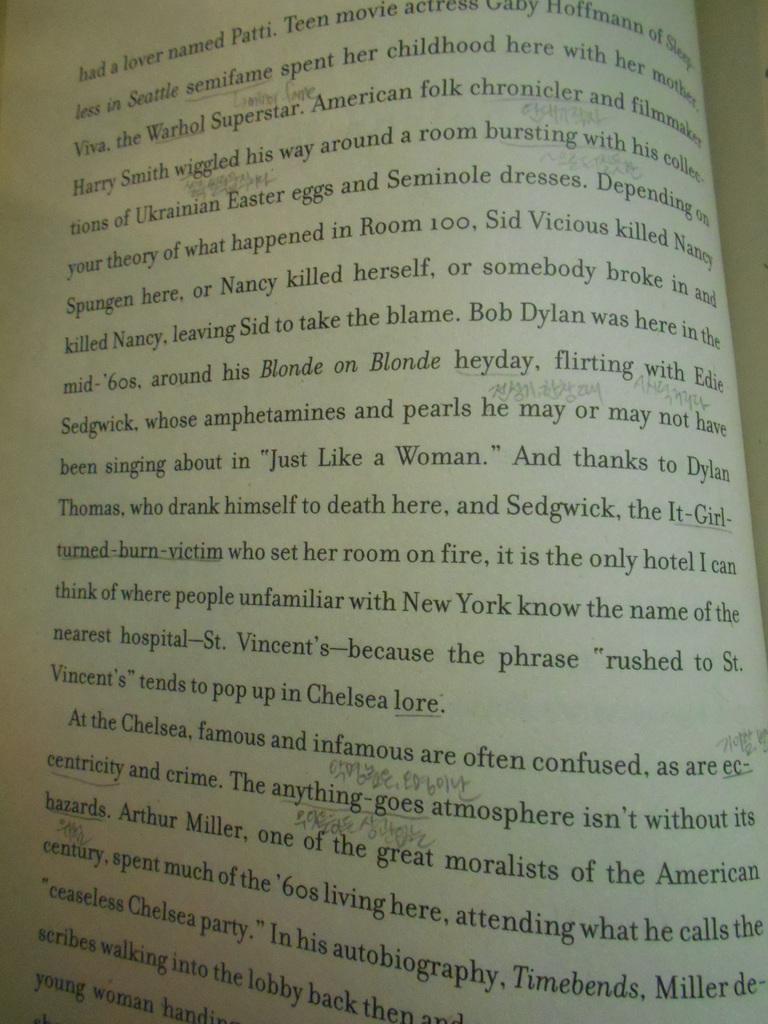What lore does it mention at the end of the paragraph?
Offer a terse response. Chelsea. Who did sid vicious kill?
Offer a very short reply. Nancy spungen. 